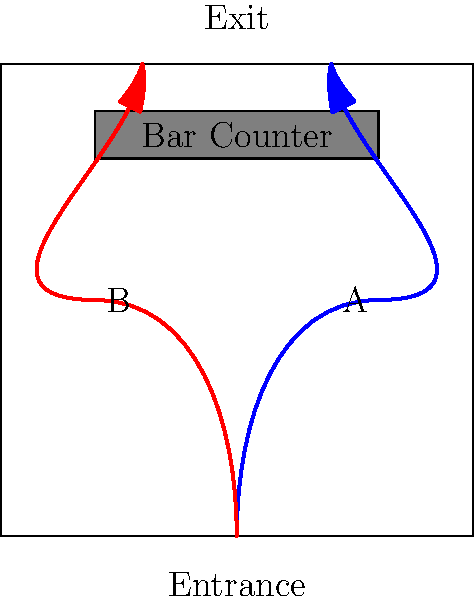In the wine bar layout shown above, two potential customer flow paths (A in blue and B in red) are illustrated. Which path is likely to provide a better customer experience and potentially increase sales? Explain your reasoning based on the principles of customer flow and bar layout optimization. To determine the optimal customer flow path, we need to consider several factors:

1. Bar visibility and accessibility:
   Path A (blue) brings customers closer to the bar counter, making it more visible and accessible. This can lead to increased impulse purchases and easier ordering.

2. Traffic congestion:
   Path B (red) may cause congestion near the entrance as customers enter and exit through the same area. Path A creates a more circular flow, reducing bottlenecks.

3. Product exposure:
   Path A allows customers to see more of the bar area, potentially exposing them to a wider range of products and promotional displays.

4. Social interaction:
   Path A encourages customers to move through the center of the bar, promoting social interaction and a lively atmosphere.

5. Staff efficiency:
   With Path A, staff can more easily serve customers along the bar counter and monitor the entire space.

6. Psychological factors:
   Most customers naturally tend to move counterclockwise and prefer right-hand turns, which aligns with Path A.

7. Exit strategy:
   Path A provides a clear and intuitive route to the exit, ensuring smooth customer turnover.

Given these considerations, Path A (blue) is likely to provide a better customer experience and potentially increase sales. It maximizes bar visibility, reduces congestion, increases product exposure, and aligns with natural customer movement patterns.
Answer: Path A (blue) 